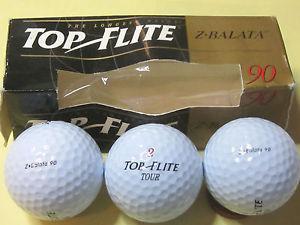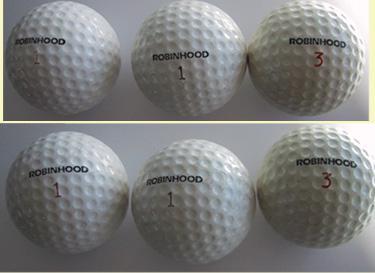The first image is the image on the left, the second image is the image on the right. Assess this claim about the two images: "An image includes at least one golf ball out of its package, next to a box made to hold a few balls.". Correct or not? Answer yes or no. Yes. The first image is the image on the left, the second image is the image on the right. For the images shown, is this caption "All of the golf balls are inside boxes." true? Answer yes or no. No. 